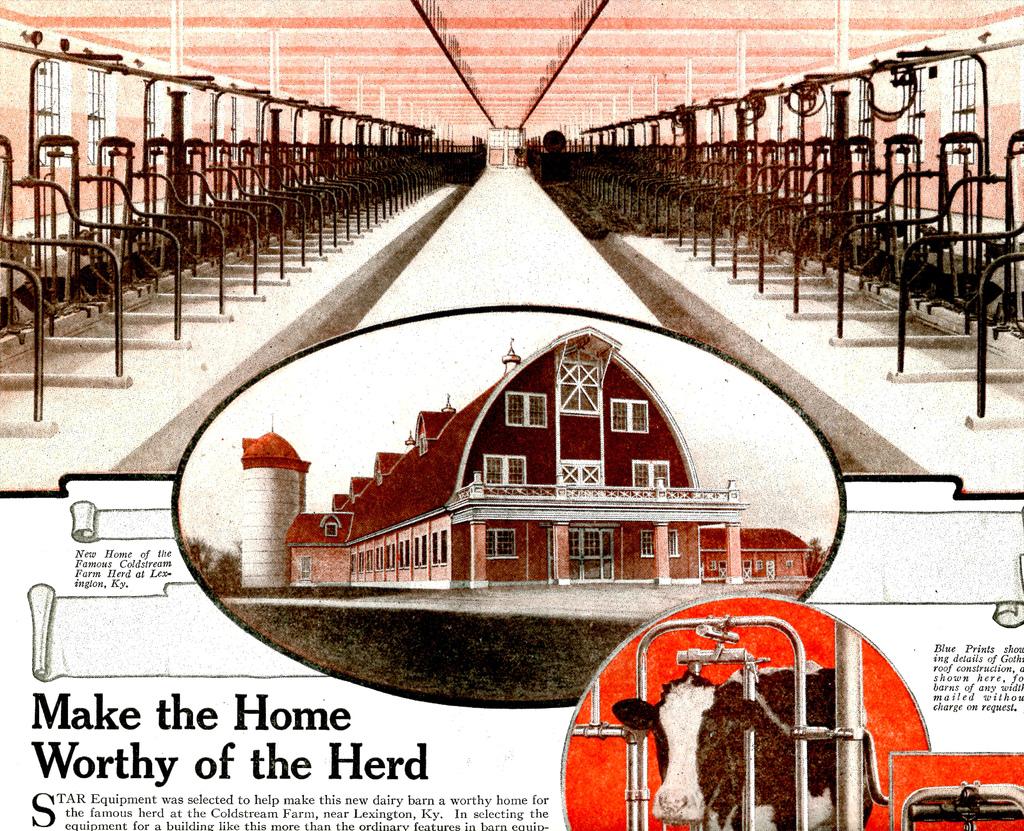What is the article title?
Offer a very short reply. Make the home worthy of the herd. 